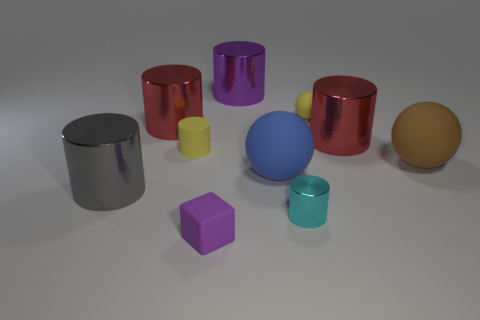Subtract all cyan cubes. Subtract all cyan cylinders. How many cubes are left? 1 Subtract all purple blocks. How many red cylinders are left? 2 Add 10 blues. How many tiny cyans exist? 0 Subtract all blue spheres. Subtract all blue matte balls. How many objects are left? 8 Add 5 large red cylinders. How many large red cylinders are left? 7 Add 4 yellow balls. How many yellow balls exist? 5 Subtract all yellow spheres. How many spheres are left? 2 Subtract all brown rubber balls. How many balls are left? 2 Subtract 0 green blocks. How many objects are left? 10 Subtract all cubes. How many objects are left? 9 